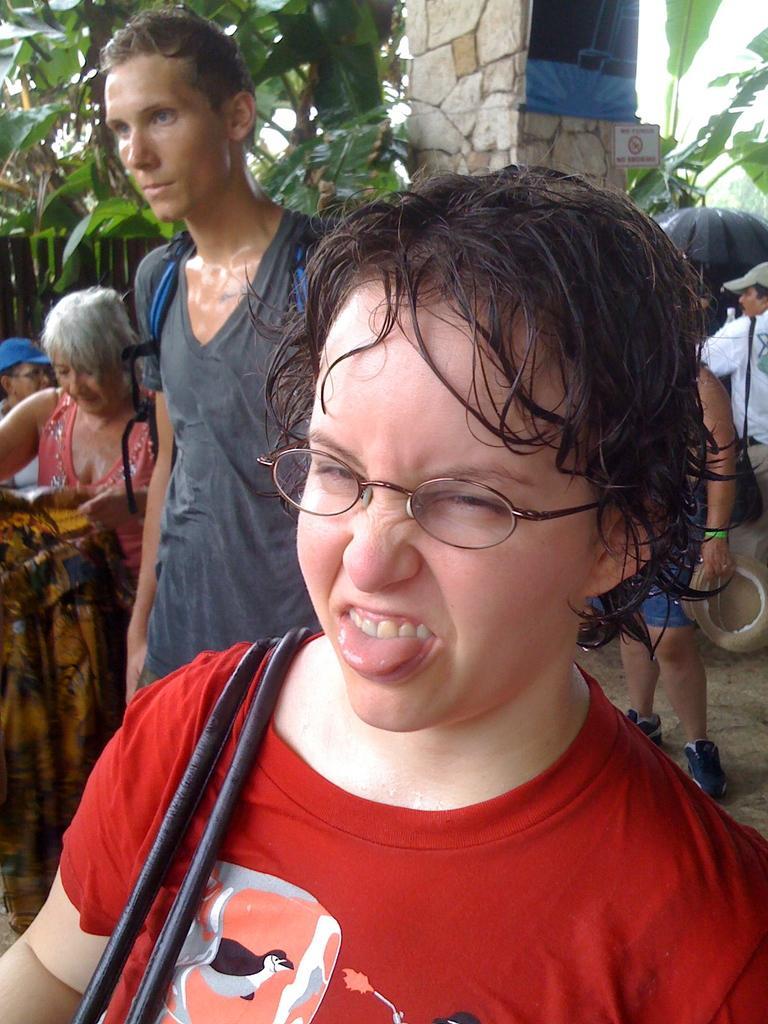Describe this image in one or two sentences. In this image, there are a few people. We can see the ground and a pillar. There are a few trees. We can also see the fence and a board. 